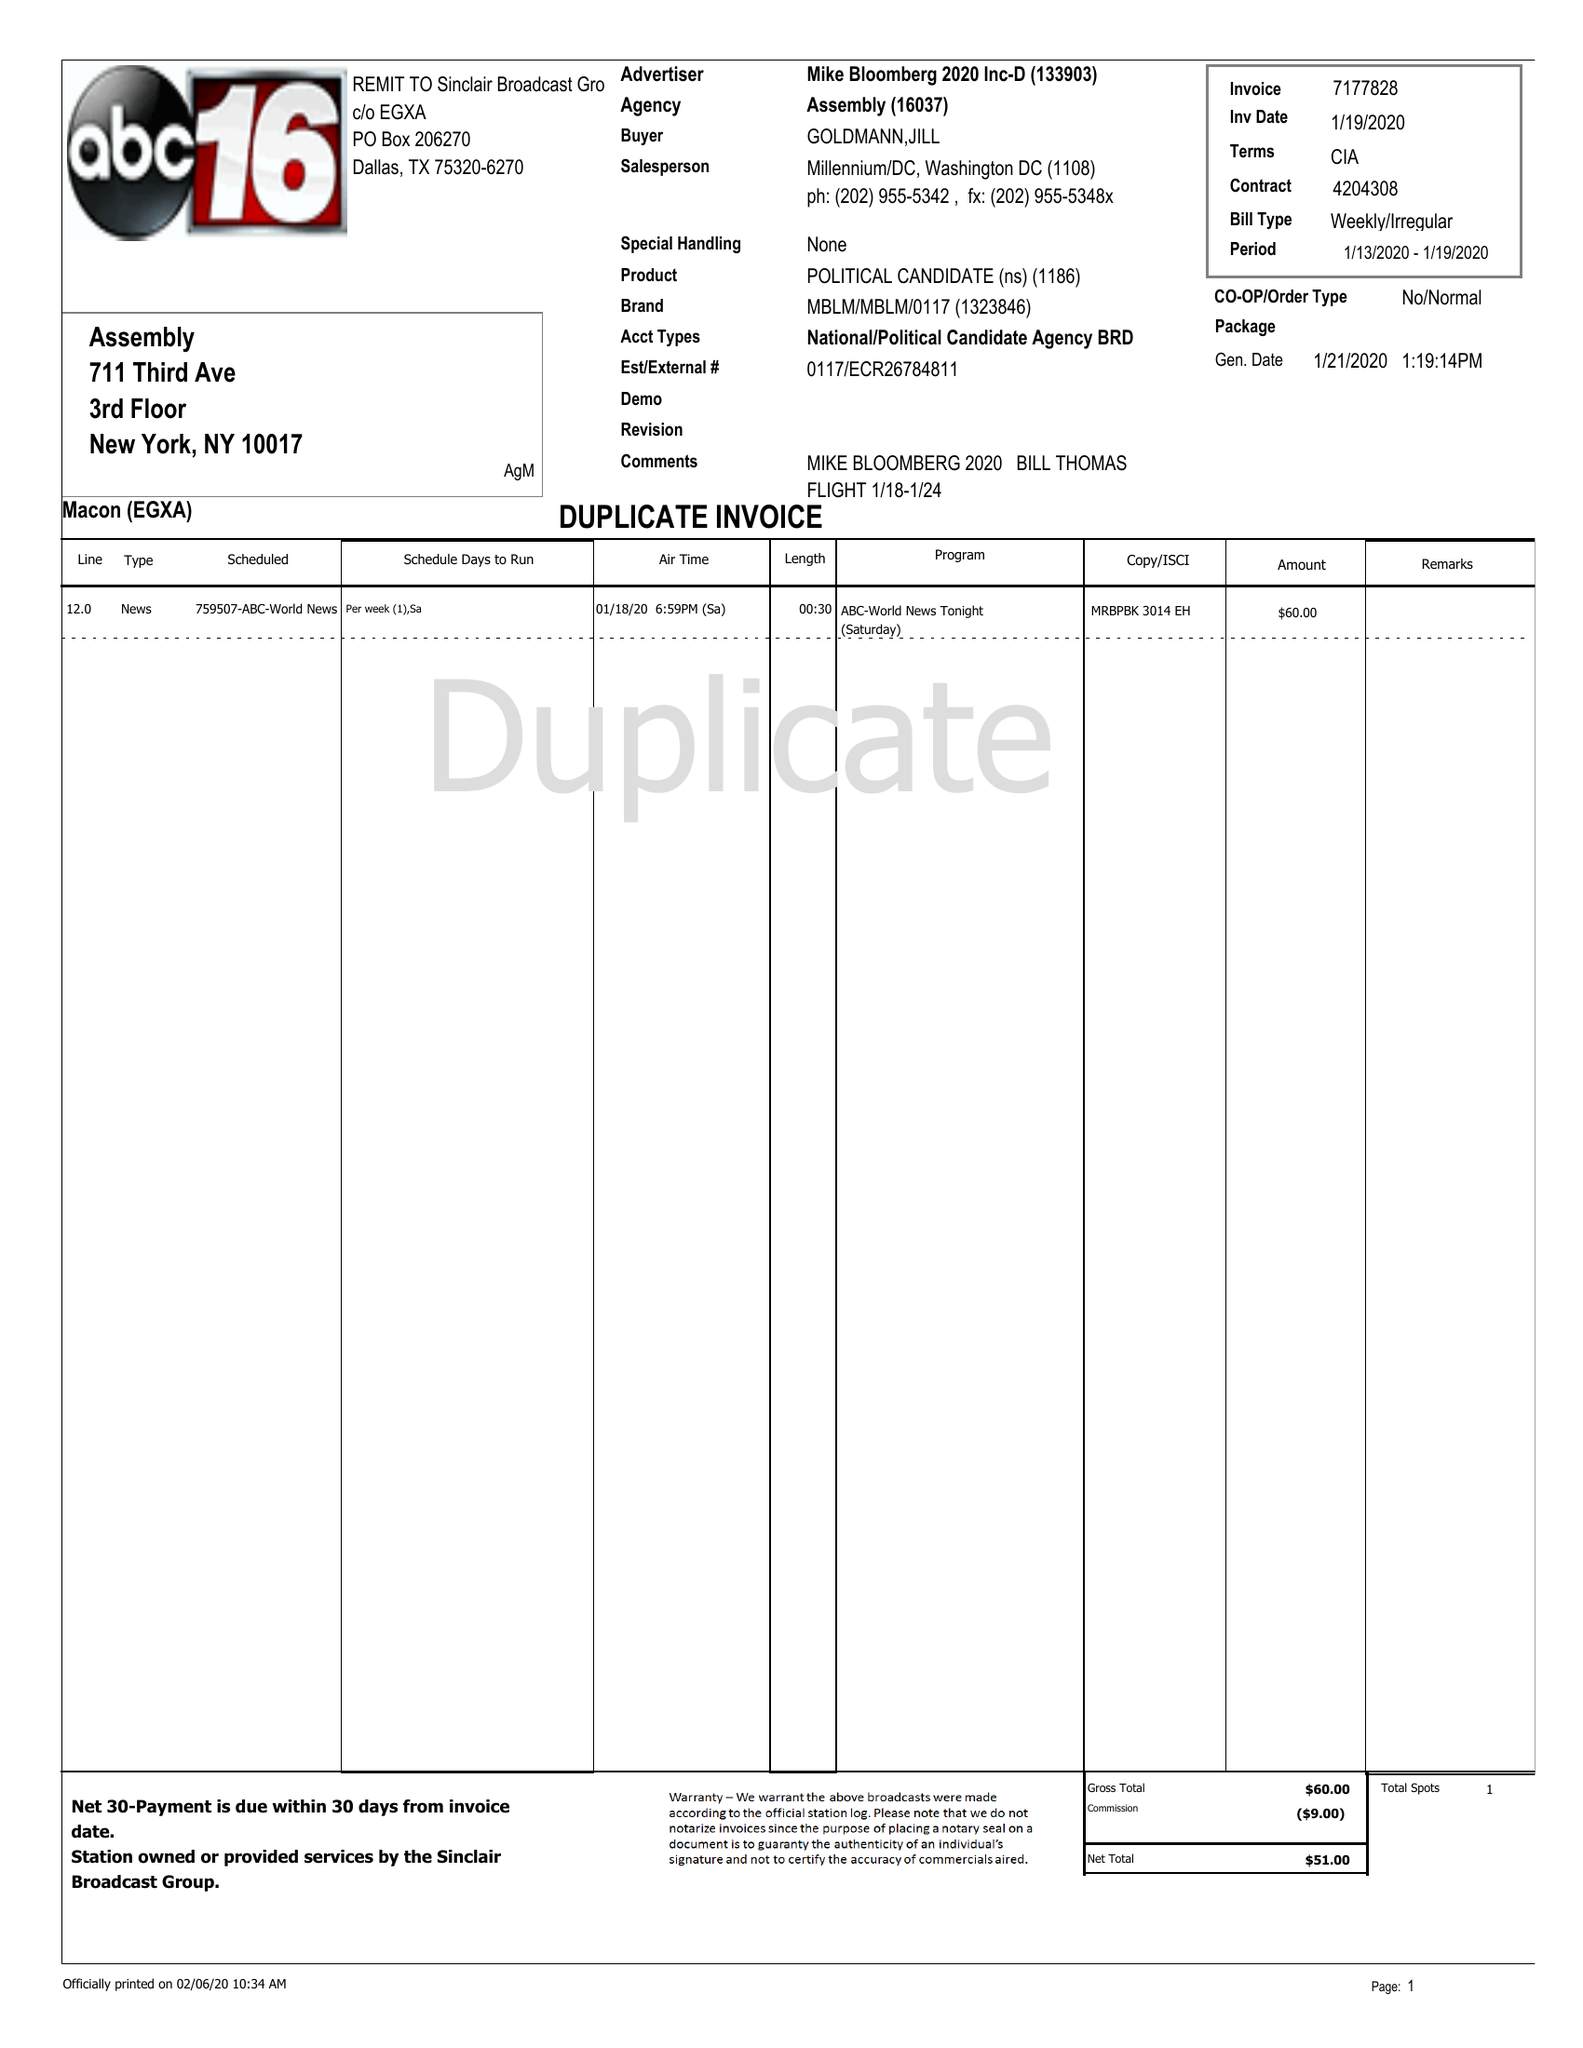What is the value for the advertiser?
Answer the question using a single word or phrase. MIKE BLOOMBERG 2020 INC-D 